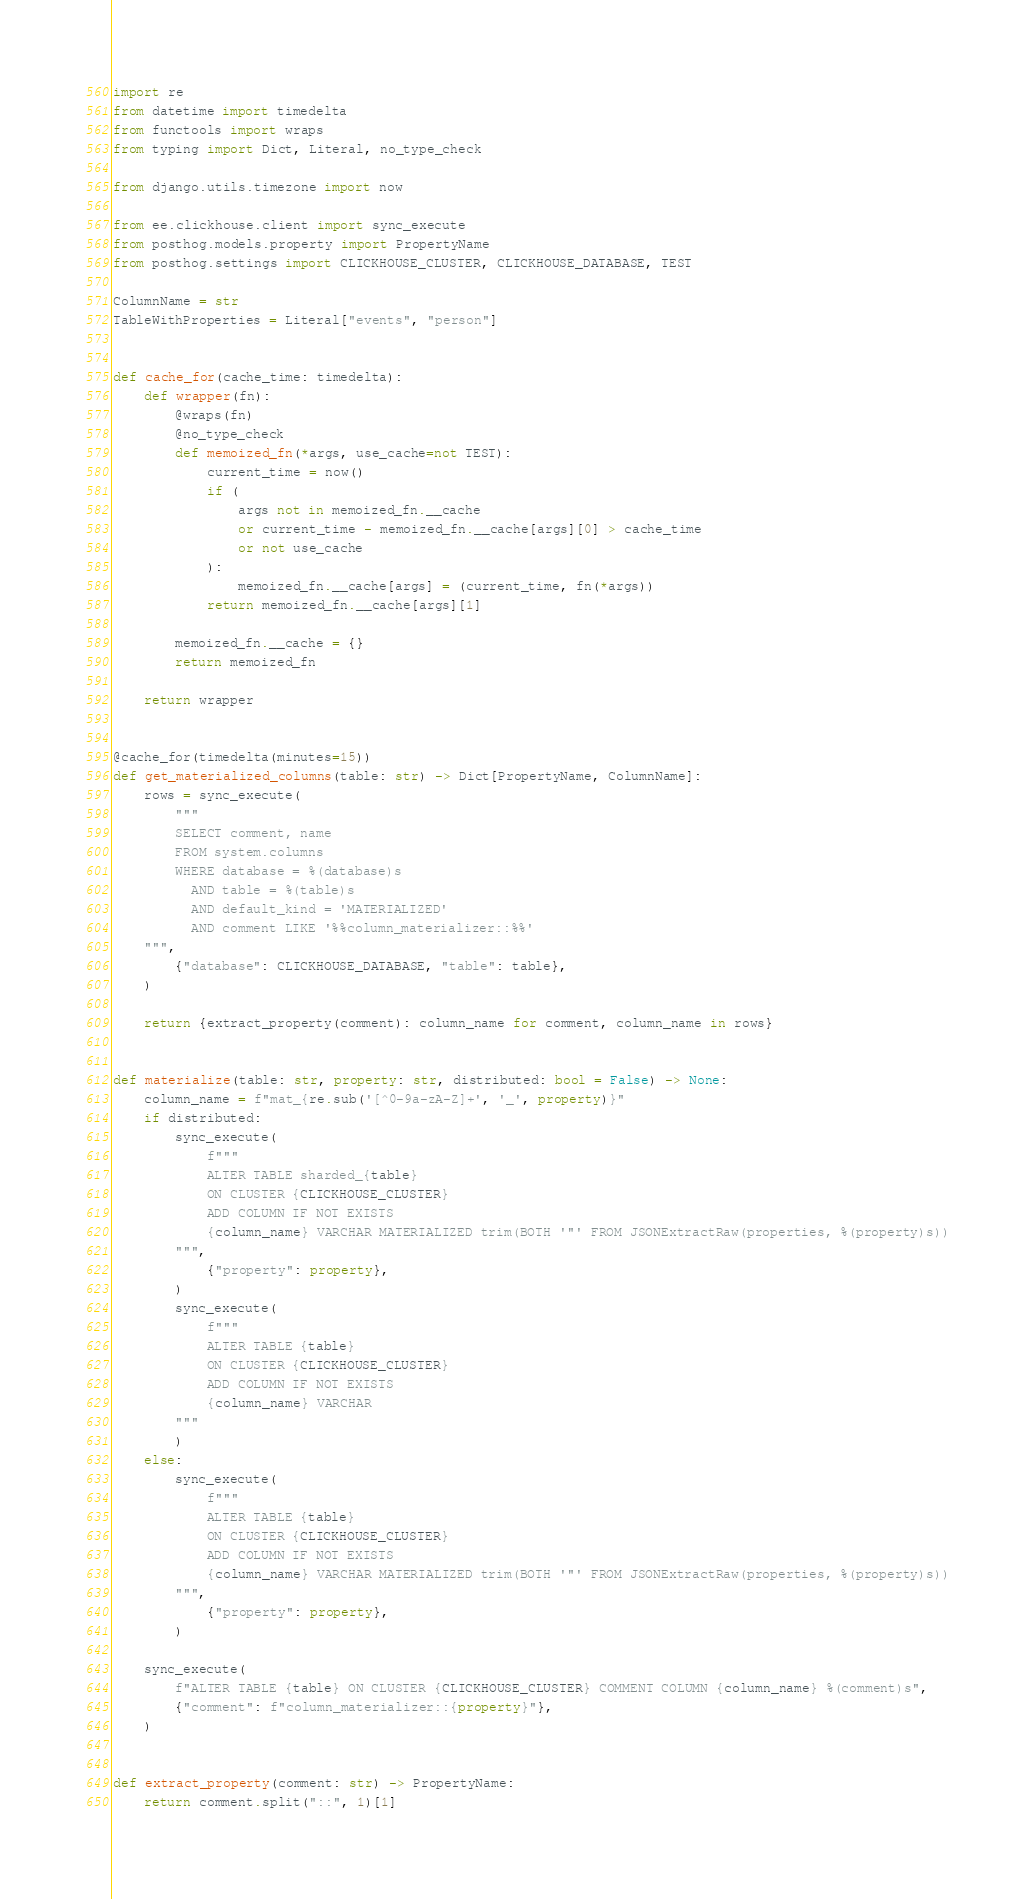Convert code to text. <code><loc_0><loc_0><loc_500><loc_500><_Python_>import re
from datetime import timedelta
from functools import wraps
from typing import Dict, Literal, no_type_check

from django.utils.timezone import now

from ee.clickhouse.client import sync_execute
from posthog.models.property import PropertyName
from posthog.settings import CLICKHOUSE_CLUSTER, CLICKHOUSE_DATABASE, TEST

ColumnName = str
TableWithProperties = Literal["events", "person"]


def cache_for(cache_time: timedelta):
    def wrapper(fn):
        @wraps(fn)
        @no_type_check
        def memoized_fn(*args, use_cache=not TEST):
            current_time = now()
            if (
                args not in memoized_fn.__cache
                or current_time - memoized_fn.__cache[args][0] > cache_time
                or not use_cache
            ):
                memoized_fn.__cache[args] = (current_time, fn(*args))
            return memoized_fn.__cache[args][1]

        memoized_fn.__cache = {}
        return memoized_fn

    return wrapper


@cache_for(timedelta(minutes=15))
def get_materialized_columns(table: str) -> Dict[PropertyName, ColumnName]:
    rows = sync_execute(
        """
        SELECT comment, name
        FROM system.columns
        WHERE database = %(database)s
          AND table = %(table)s
          AND default_kind = 'MATERIALIZED'
          AND comment LIKE '%%column_materializer::%%'
    """,
        {"database": CLICKHOUSE_DATABASE, "table": table},
    )

    return {extract_property(comment): column_name for comment, column_name in rows}


def materialize(table: str, property: str, distributed: bool = False) -> None:
    column_name = f"mat_{re.sub('[^0-9a-zA-Z]+', '_', property)}"
    if distributed:
        sync_execute(
            f"""
            ALTER TABLE sharded_{table}
            ON CLUSTER {CLICKHOUSE_CLUSTER}
            ADD COLUMN IF NOT EXISTS
            {column_name} VARCHAR MATERIALIZED trim(BOTH '"' FROM JSONExtractRaw(properties, %(property)s))
        """,
            {"property": property},
        )
        sync_execute(
            f"""
            ALTER TABLE {table}
            ON CLUSTER {CLICKHOUSE_CLUSTER}
            ADD COLUMN IF NOT EXISTS
            {column_name} VARCHAR
        """
        )
    else:
        sync_execute(
            f"""
            ALTER TABLE {table}
            ON CLUSTER {CLICKHOUSE_CLUSTER}
            ADD COLUMN IF NOT EXISTS
            {column_name} VARCHAR MATERIALIZED trim(BOTH '"' FROM JSONExtractRaw(properties, %(property)s))
        """,
            {"property": property},
        )

    sync_execute(
        f"ALTER TABLE {table} ON CLUSTER {CLICKHOUSE_CLUSTER} COMMENT COLUMN {column_name} %(comment)s",
        {"comment": f"column_materializer::{property}"},
    )


def extract_property(comment: str) -> PropertyName:
    return comment.split("::", 1)[1]
</code> 